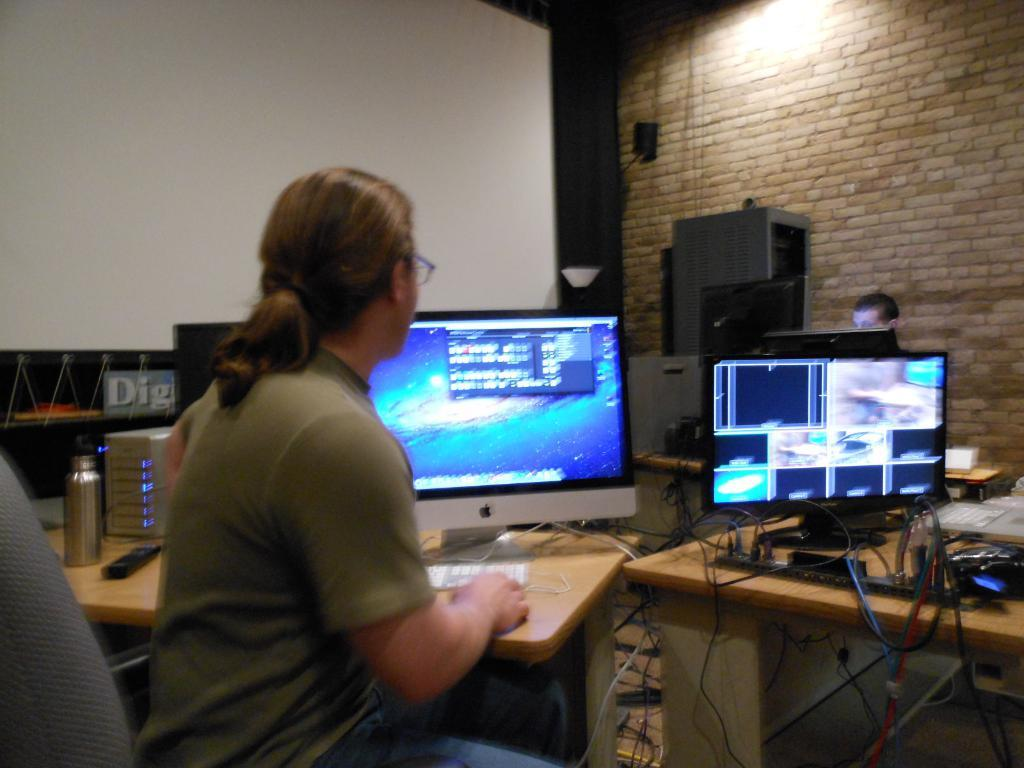<image>
Summarize the visual content of the image. A sign under the projector screen says DIG. 